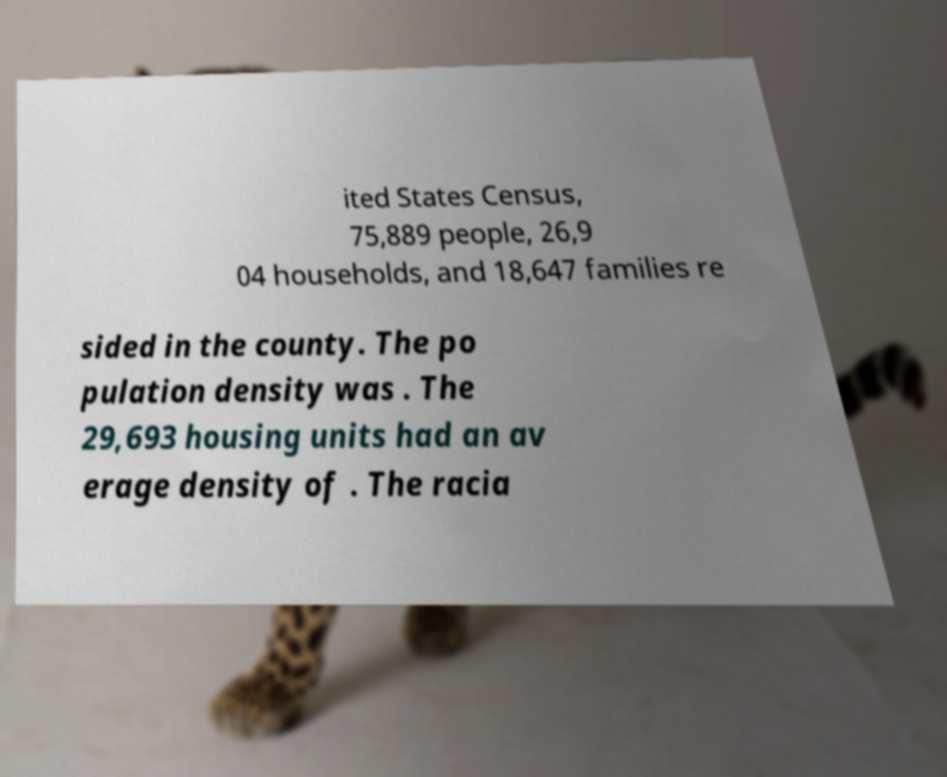What messages or text are displayed in this image? I need them in a readable, typed format. ited States Census, 75,889 people, 26,9 04 households, and 18,647 families re sided in the county. The po pulation density was . The 29,693 housing units had an av erage density of . The racia 